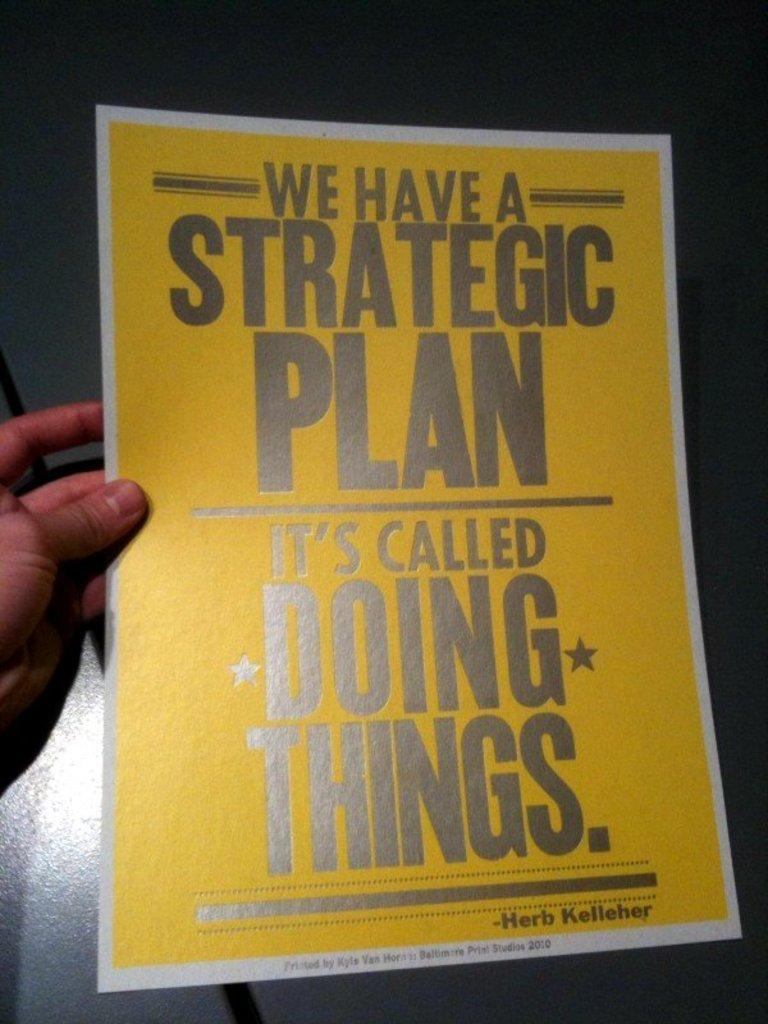<image>
Present a compact description of the photo's key features. A poster talks about having a strategic plan. 